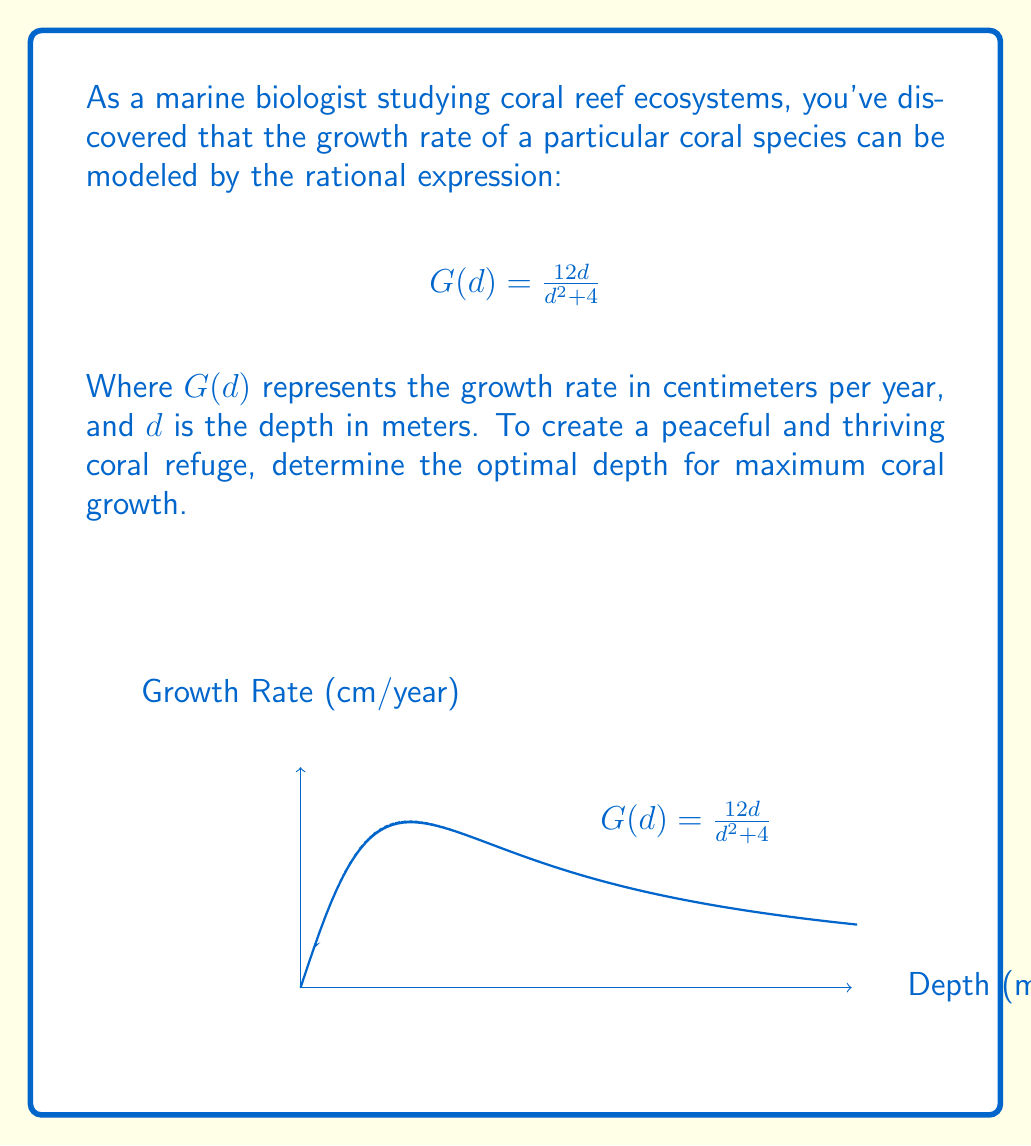Can you solve this math problem? To find the optimal depth for maximum coral growth, we need to determine the maximum value of the rational function $G(d)$. We can do this by following these steps:

1) First, let's find the derivative of $G(d)$ using the quotient rule:

   $$G'(d) = \frac{(d^2+4)(12) - 12d(2d)}{(d^2+4)^2}$$

2) Simplify the numerator:

   $$G'(d) = \frac{12d^2 + 48 - 24d^2}{(d^2+4)^2} = \frac{48 - 12d^2}{(d^2+4)^2}$$

3) To find the maximum, set $G'(d) = 0$ and solve for $d$:

   $$\frac{48 - 12d^2}{(d^2+4)^2} = 0$$

4) The denominator is always positive, so we only need to solve:

   $$48 - 12d^2 = 0$$

5) Solve for $d$:

   $$12d^2 = 48$$
   $$d^2 = 4$$
   $$d = \pm 2$$

6) Since depth cannot be negative, we take the positive solution: $d = 2$.

7) To confirm this is a maximum (not a minimum), we can check the second derivative or observe the behavior of the function around this point.

Therefore, the optimal depth for maximum coral growth is 2 meters.
Answer: 2 meters 